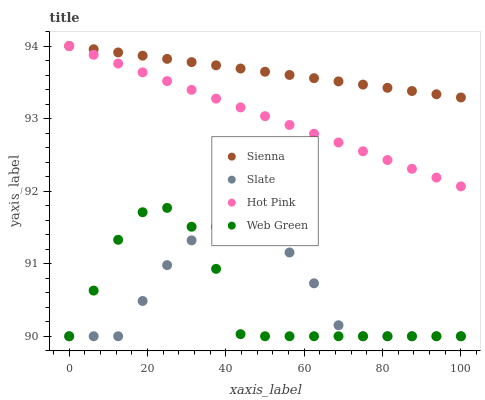Does Web Green have the minimum area under the curve?
Answer yes or no. Yes. Does Sienna have the maximum area under the curve?
Answer yes or no. Yes. Does Slate have the minimum area under the curve?
Answer yes or no. No. Does Slate have the maximum area under the curve?
Answer yes or no. No. Is Hot Pink the smoothest?
Answer yes or no. Yes. Is Web Green the roughest?
Answer yes or no. Yes. Is Slate the smoothest?
Answer yes or no. No. Is Slate the roughest?
Answer yes or no. No. Does Slate have the lowest value?
Answer yes or no. Yes. Does Hot Pink have the lowest value?
Answer yes or no. No. Does Hot Pink have the highest value?
Answer yes or no. Yes. Does Slate have the highest value?
Answer yes or no. No. Is Web Green less than Hot Pink?
Answer yes or no. Yes. Is Sienna greater than Web Green?
Answer yes or no. Yes. Does Sienna intersect Hot Pink?
Answer yes or no. Yes. Is Sienna less than Hot Pink?
Answer yes or no. No. Is Sienna greater than Hot Pink?
Answer yes or no. No. Does Web Green intersect Hot Pink?
Answer yes or no. No. 